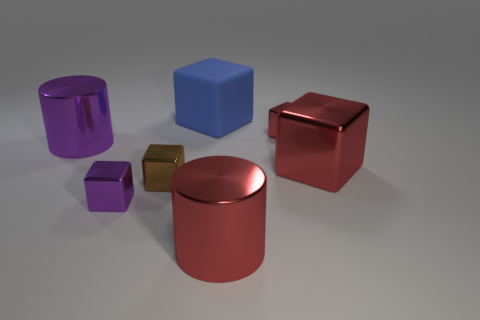Is there anything else that is the same material as the blue object?
Make the answer very short. No. Is there a purple object that has the same shape as the large blue matte thing?
Your answer should be compact. Yes. The large object that is both on the right side of the blue rubber thing and behind the tiny brown block has what shape?
Make the answer very short. Cube. Are the brown object and the blue block that is behind the brown metallic cube made of the same material?
Offer a very short reply. No. There is a rubber block; are there any big red metal cylinders behind it?
Your response must be concise. No. What number of objects are either small purple blocks or metallic cubes on the left side of the rubber object?
Your response must be concise. 2. There is a small thing that is left of the brown object in front of the blue rubber cube; what is its color?
Offer a very short reply. Purple. How many other things are the same material as the big purple thing?
Your answer should be compact. 5. What number of matte objects are brown objects or large purple objects?
Offer a terse response. 0. What color is the other large rubber thing that is the same shape as the brown object?
Provide a short and direct response. Blue. 